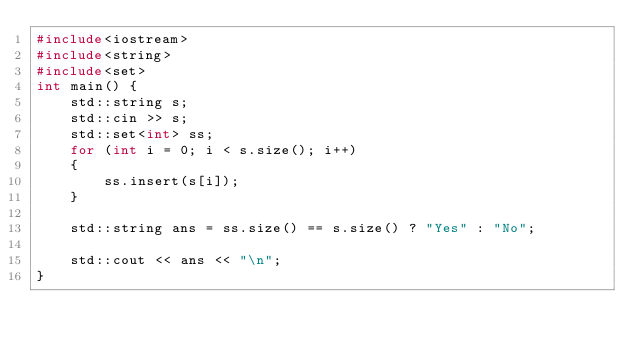<code> <loc_0><loc_0><loc_500><loc_500><_C++_>#include<iostream>
#include<string>
#include<set>
int main() {
    std::string s;
    std::cin >> s;
    std::set<int> ss;
    for (int i = 0; i < s.size(); i++)
    {
        ss.insert(s[i]);
    }

    std::string ans = ss.size() == s.size() ? "Yes" : "No";

    std::cout << ans << "\n";
}</code> 